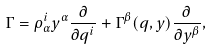<formula> <loc_0><loc_0><loc_500><loc_500>\Gamma = \rho ^ { i } _ { \alpha } y ^ { \alpha } \frac { \partial } { \partial q ^ { i } } + \Gamma ^ { \beta } ( q , y ) \frac { \partial } { \partial y ^ { \beta } } ,</formula> 